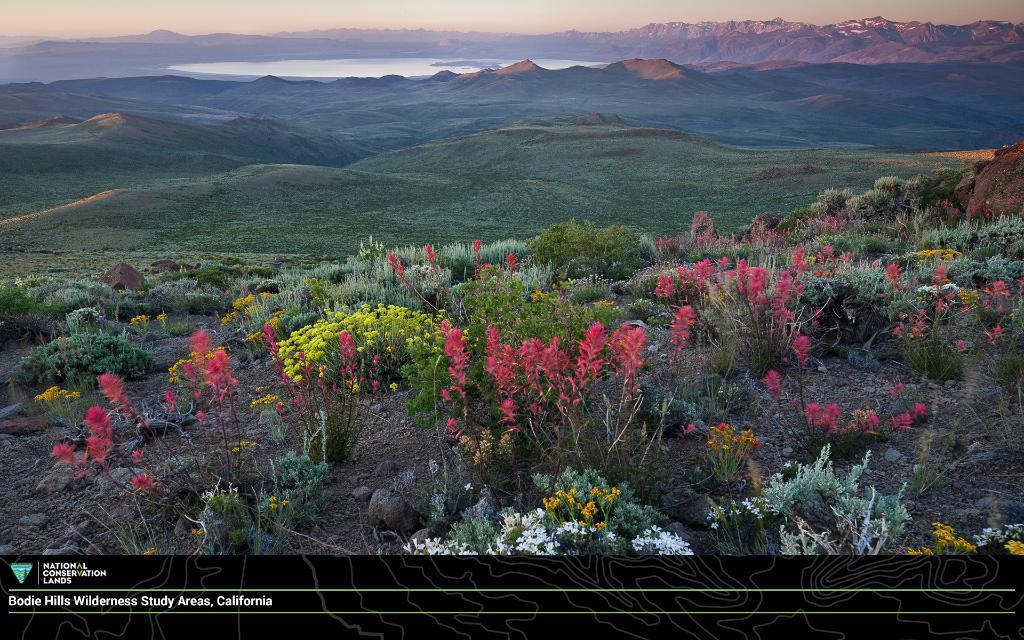How would you summarize this image in a sentence or two? At the bottom of the image there are flower plants. In the background of the image there are mountains. There is grass. There is water. 